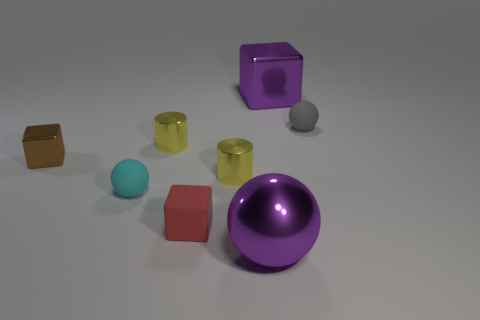Are the large purple thing that is in front of the cyan thing and the small red cube made of the same material?
Your response must be concise. No. There is a cube that is behind the tiny cyan rubber object and left of the purple metallic block; how big is it?
Offer a terse response. Small. The big shiny sphere has what color?
Ensure brevity in your answer.  Purple. How many gray spheres are there?
Provide a succinct answer. 1. What number of tiny matte balls are the same color as the large cube?
Your answer should be very brief. 0. There is a purple shiny object behind the red object; is it the same shape as the small brown shiny thing that is behind the red thing?
Offer a terse response. Yes. There is a small thing that is on the right side of the large purple shiny object behind the rubber ball that is to the right of the large purple sphere; what is its color?
Make the answer very short. Gray. What color is the small ball that is on the right side of the tiny cyan matte thing?
Your answer should be very brief. Gray. There is a metallic object that is the same size as the purple metal block; what color is it?
Provide a succinct answer. Purple. Is the brown shiny object the same size as the purple cube?
Make the answer very short. No. 